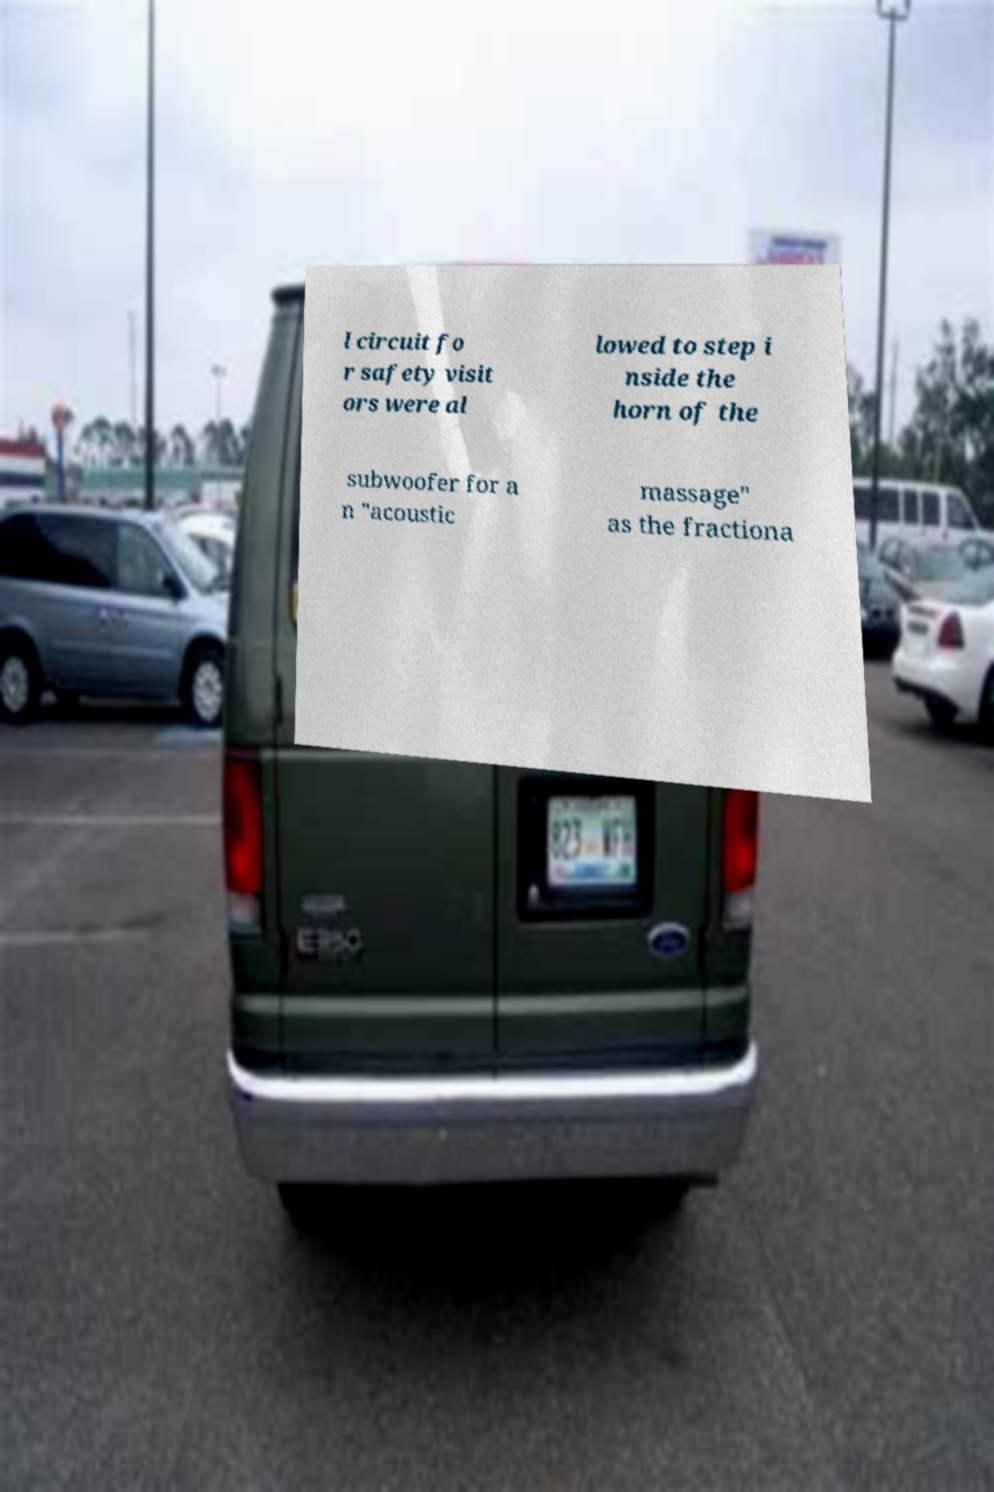There's text embedded in this image that I need extracted. Can you transcribe it verbatim? l circuit fo r safety visit ors were al lowed to step i nside the horn of the subwoofer for a n "acoustic massage" as the fractiona 